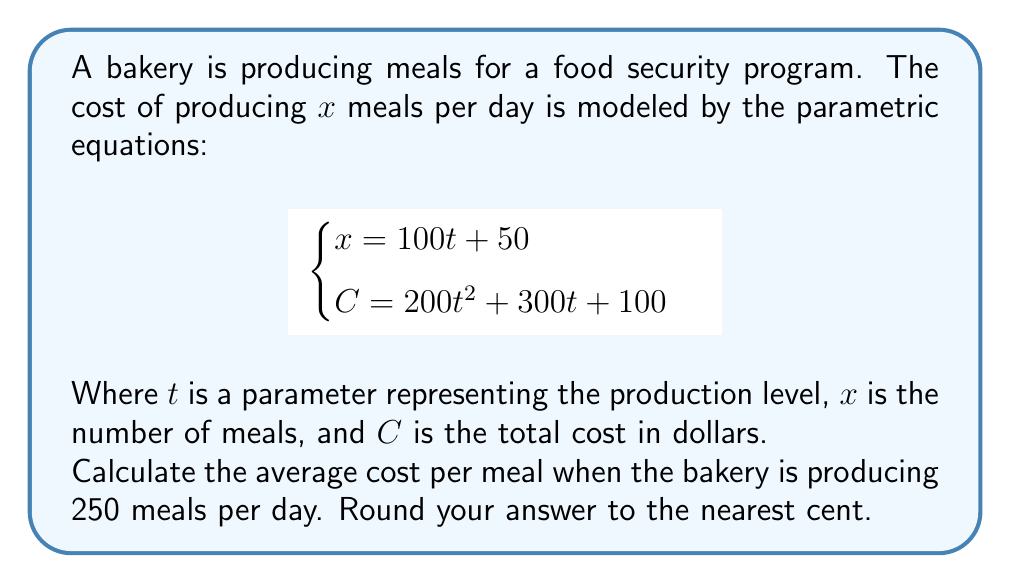Can you solve this math problem? To solve this problem, we'll follow these steps:

1) First, we need to find the value of $t$ when $x = 250$. We can use the first equation:
   
   $x = 100t + 50$
   $250 = 100t + 50$
   $200 = 100t$
   $t = 2$

2) Now that we know $t = 2$, we can substitute this into the second equation to find the total cost:
   
   $C = 200t^2 + 300t + 100$
   $C = 200(2)^2 + 300(2) + 100$
   $C = 200(4) + 600 + 100$
   $C = 800 + 600 + 100$
   $C = 1500$

3) The average cost per meal is the total cost divided by the number of meals:

   Average cost per meal = $\frac{C}{x} = \frac{1500}{250} = 6$

Therefore, the average cost per meal is $6.00.
Answer: $6.00 per meal 